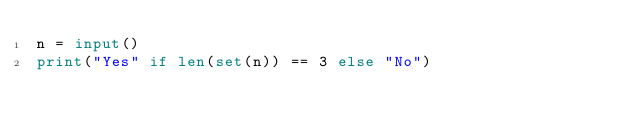<code> <loc_0><loc_0><loc_500><loc_500><_Python_>n = input()
print("Yes" if len(set(n)) == 3 else "No")</code> 